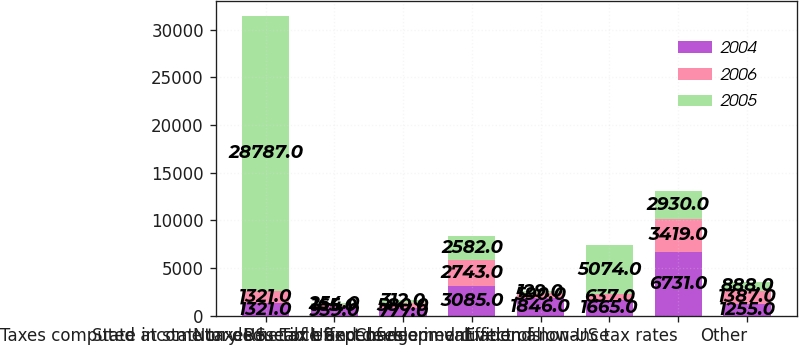Convert chart. <chart><loc_0><loc_0><loc_500><loc_500><stacked_bar_chart><ecel><fcel>Taxes computed at statutory US<fcel>State income taxes net of US<fcel>Non-deductible expenses<fcel>Research and development<fcel>Tax effect of deemed dividends<fcel>Change in valuation allowance<fcel>Effect of non-US tax rates<fcel>Other<nl><fcel>2004<fcel>1321<fcel>939<fcel>777<fcel>3085<fcel>1846<fcel>1665<fcel>6731<fcel>1255<nl><fcel>2006<fcel>1321<fcel>165<fcel>580<fcel>2743<fcel>590<fcel>637<fcel>3419<fcel>1387<nl><fcel>2005<fcel>28787<fcel>254<fcel>312<fcel>2582<fcel>129<fcel>5074<fcel>2930<fcel>888<nl></chart> 